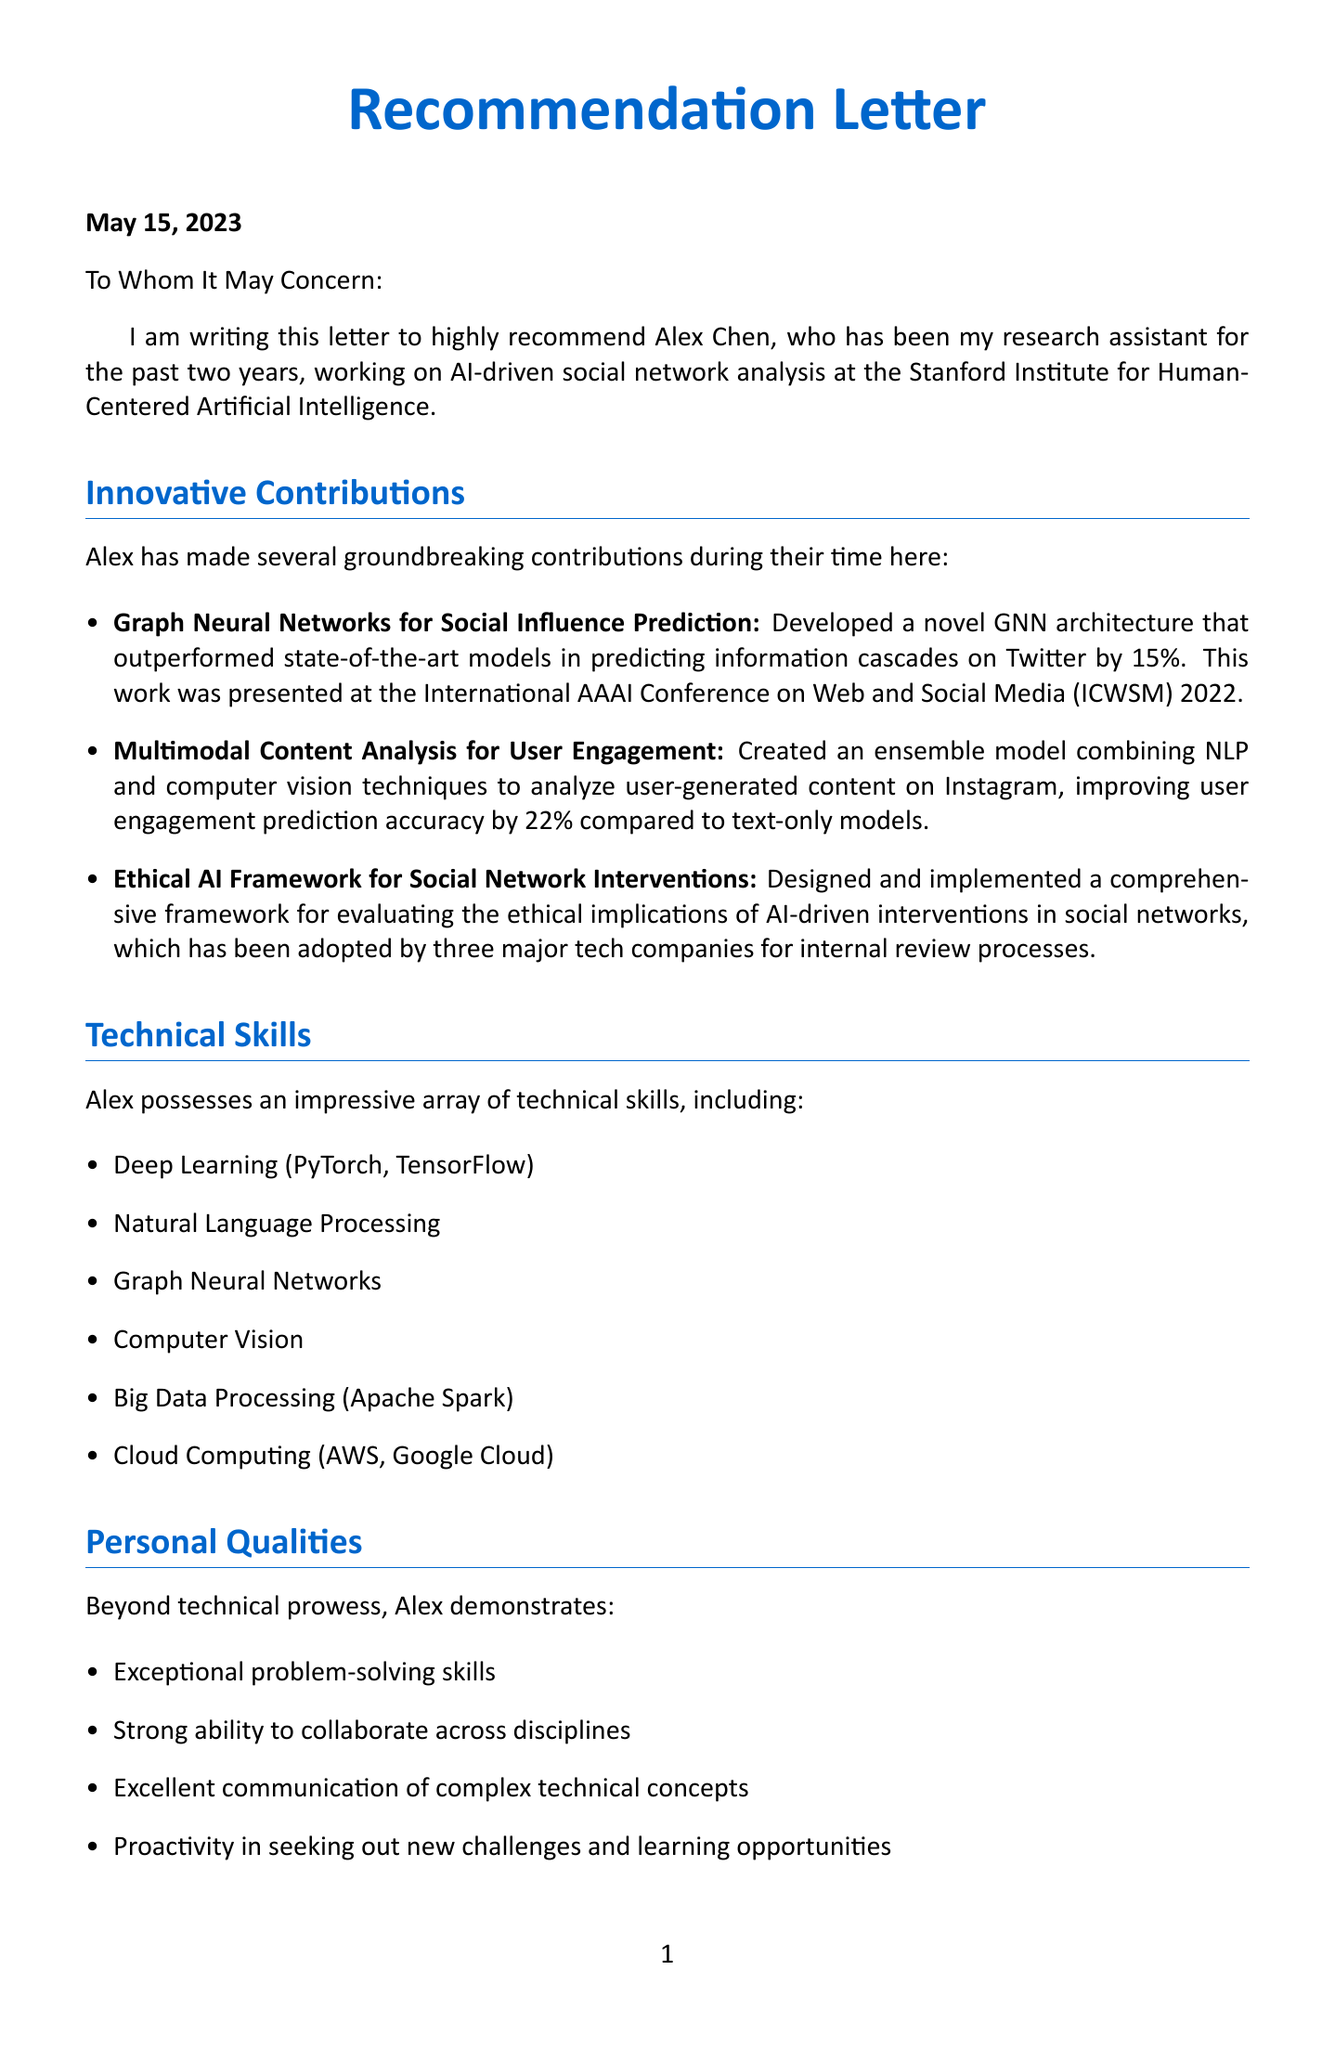What is the date of the letter? The date of the letter is specified in the header section of the document.
Answer: May 15, 2023 Who is the sender of the letter? The sender's name and title are provided at the beginning of the letter.
Answer: Dr. Javier Rodríguez What is the main project Alex Chen worked on? The project that Alex Chen was involved in is mentioned in the introduction section of the letter.
Answer: AI-driven social network analysis How much did the GNN architecture improve prediction accuracy? This improvement is detailed in the innovative contributions section, specifically for the GNN project.
Answer: 15% Which award did Alex Chen receive in 2023? The awards section lists the recognitions Alex received, including the one in 2023.
Answer: Outstanding Graduate Researcher What is Alex Chen's research direction for the future? Future research direction is outlined in the future prospects section of the letter.
Answer: Explainable AI for social network analysis and intervention design Which company did Alex collaborate with for misinformation detection? The document specifies Alex's collaboration with industry leaders in the collaborations section.
Answer: Facebook AI Research What is the overall assessment of Alex Chen? The conclusion section evaluates Alex's potential and skills.
Answer: One of the most promising young researchers in the field of AI and social network analysis 